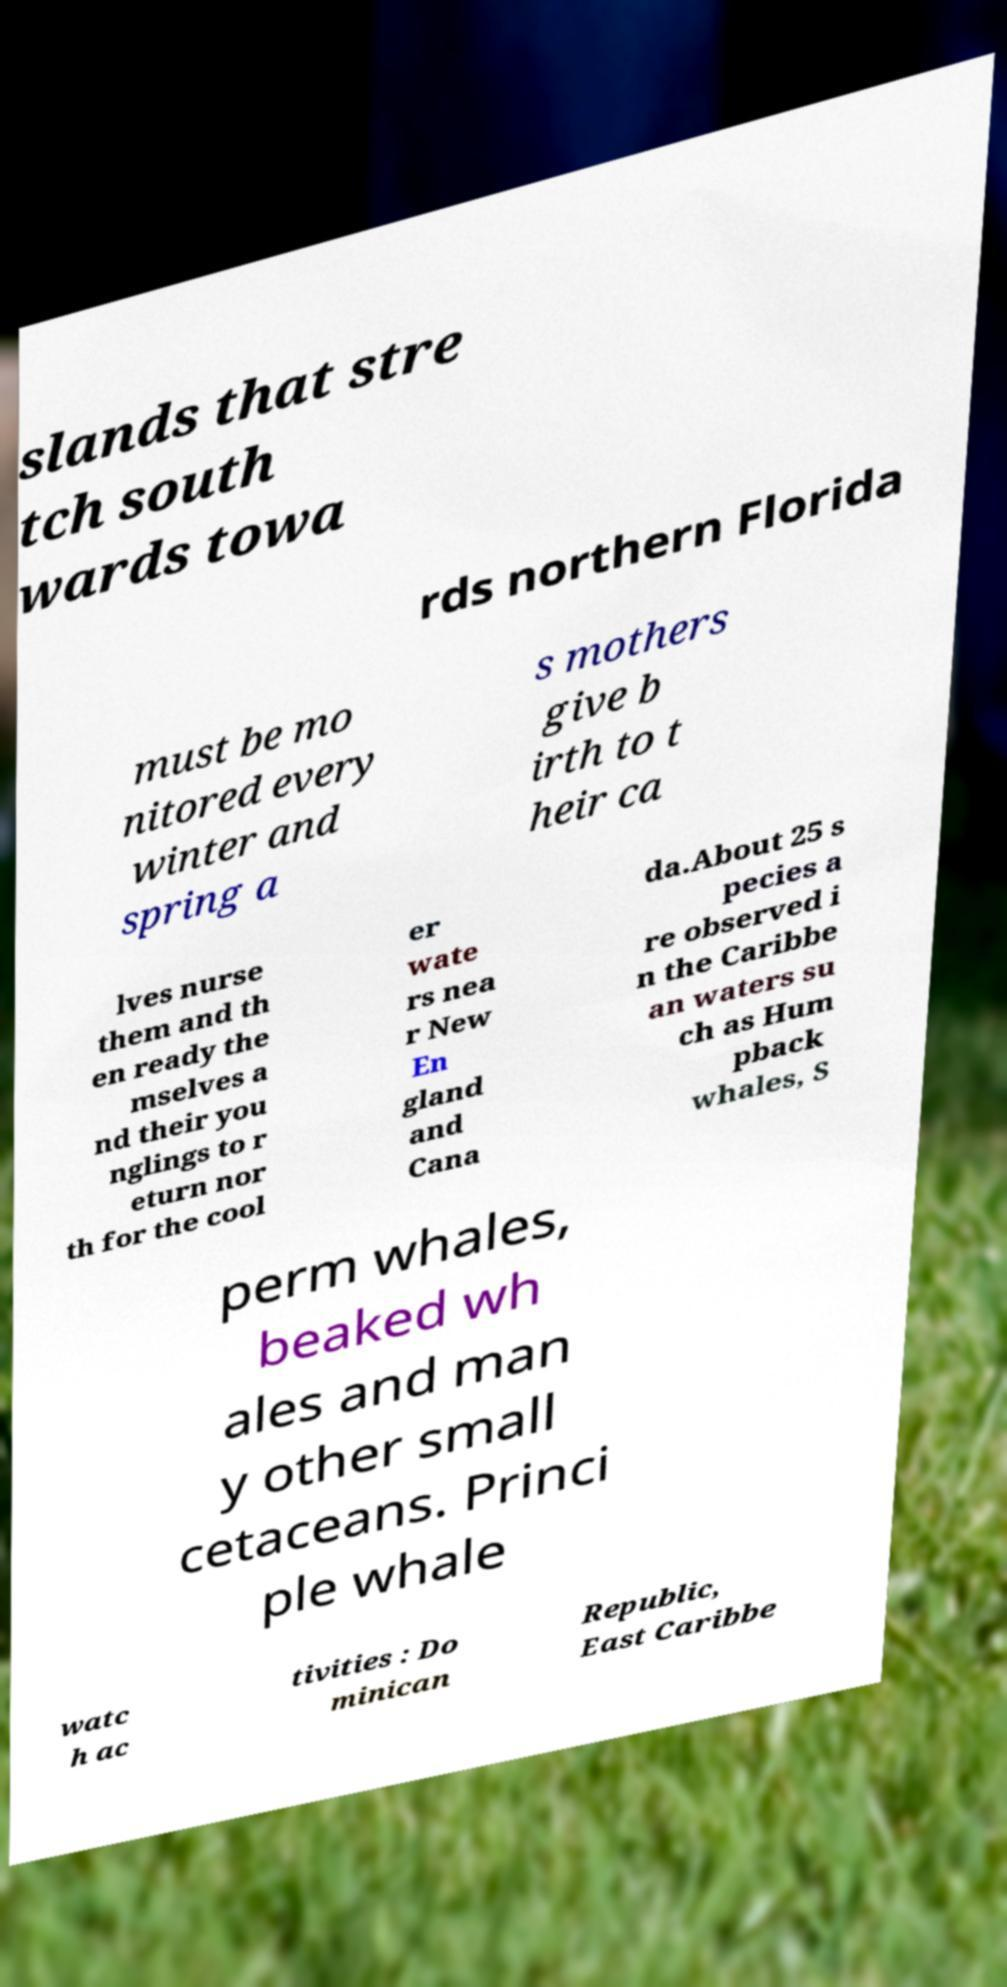Please identify and transcribe the text found in this image. slands that stre tch south wards towa rds northern Florida must be mo nitored every winter and spring a s mothers give b irth to t heir ca lves nurse them and th en ready the mselves a nd their you nglings to r eturn nor th for the cool er wate rs nea r New En gland and Cana da.About 25 s pecies a re observed i n the Caribbe an waters su ch as Hum pback whales, S perm whales, beaked wh ales and man y other small cetaceans. Princi ple whale watc h ac tivities : Do minican Republic, East Caribbe 